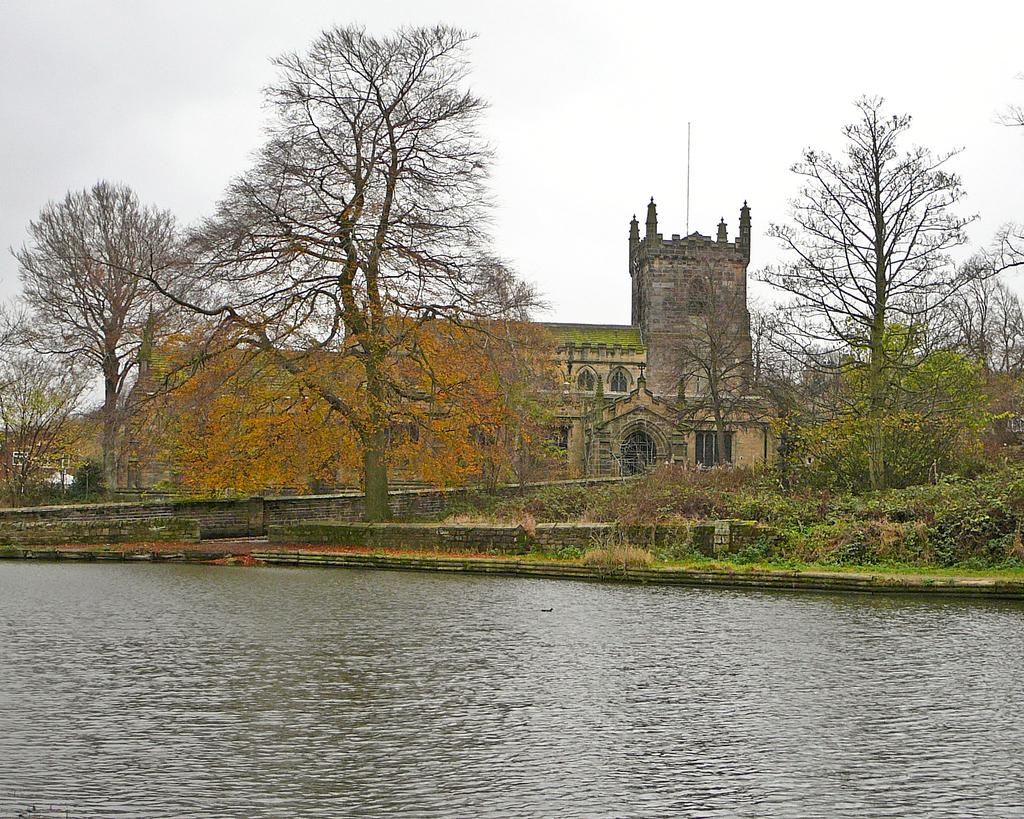What type of vegetation can be seen in the image? There are trees and plants in the image. What type of structure is present in the image? There is a building in the image. What type of architectural feature can be seen in the image? There are walls in the image. What is visible at the bottom of the image? Water is visible at the bottom of the image. What part of the natural environment is visible in the image? The sky is visible in the background of the image. Where is the store located in the image? There is no store present in the image. What date is marked on the calendar in the image? There is no calendar present in the image. 